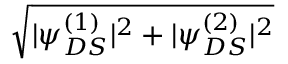<formula> <loc_0><loc_0><loc_500><loc_500>\sqrt { | \psi _ { D S } ^ { ( 1 ) } | ^ { 2 } + | \psi _ { D S } ^ { ( 2 ) } | ^ { 2 } }</formula> 